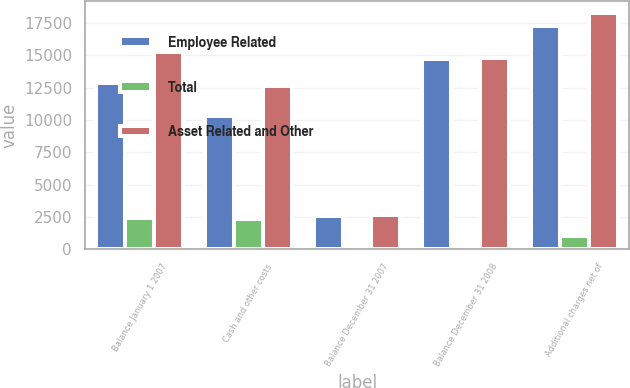Convert chart. <chart><loc_0><loc_0><loc_500><loc_500><stacked_bar_chart><ecel><fcel>Balance January 1 2007<fcel>Cash and other costs<fcel>Balance December 31 2007<fcel>Balance December 31 2008<fcel>Additional charges net of<nl><fcel>Employee Related<fcel>12861<fcel>10273<fcel>2588<fcel>14755<fcel>17263<nl><fcel>Total<fcel>2427<fcel>2361<fcel>66<fcel>66<fcel>1038<nl><fcel>Asset Related and Other<fcel>15288<fcel>12634<fcel>2654<fcel>14821<fcel>18301<nl></chart> 